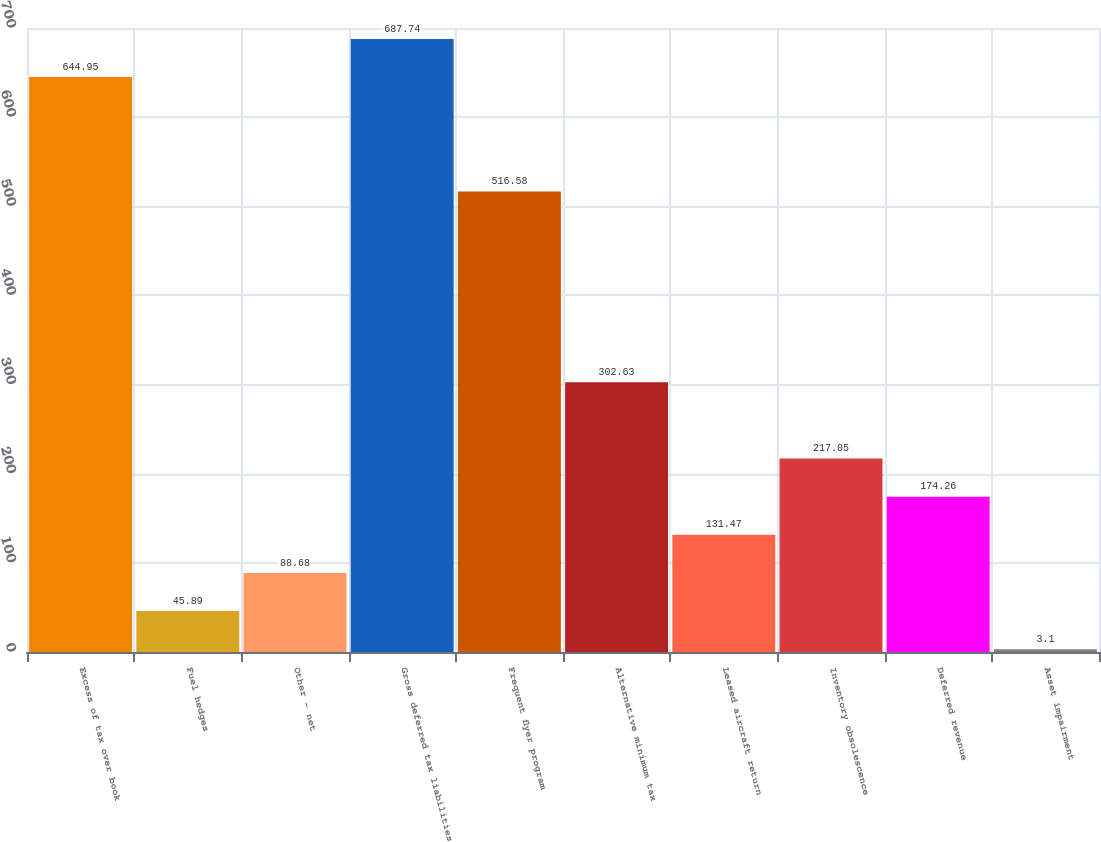Convert chart to OTSL. <chart><loc_0><loc_0><loc_500><loc_500><bar_chart><fcel>Excess of tax over book<fcel>Fuel hedges<fcel>Other - net<fcel>Gross deferred tax liabilities<fcel>Frequent flyer program<fcel>Alternative minimum tax<fcel>Leased aircraft return<fcel>Inventory obsolescence<fcel>Deferred revenue<fcel>Asset impairment<nl><fcel>644.95<fcel>45.89<fcel>88.68<fcel>687.74<fcel>516.58<fcel>302.63<fcel>131.47<fcel>217.05<fcel>174.26<fcel>3.1<nl></chart> 